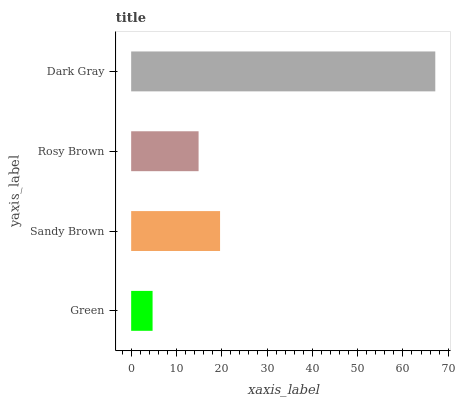Is Green the minimum?
Answer yes or no. Yes. Is Dark Gray the maximum?
Answer yes or no. Yes. Is Sandy Brown the minimum?
Answer yes or no. No. Is Sandy Brown the maximum?
Answer yes or no. No. Is Sandy Brown greater than Green?
Answer yes or no. Yes. Is Green less than Sandy Brown?
Answer yes or no. Yes. Is Green greater than Sandy Brown?
Answer yes or no. No. Is Sandy Brown less than Green?
Answer yes or no. No. Is Sandy Brown the high median?
Answer yes or no. Yes. Is Rosy Brown the low median?
Answer yes or no. Yes. Is Dark Gray the high median?
Answer yes or no. No. Is Green the low median?
Answer yes or no. No. 